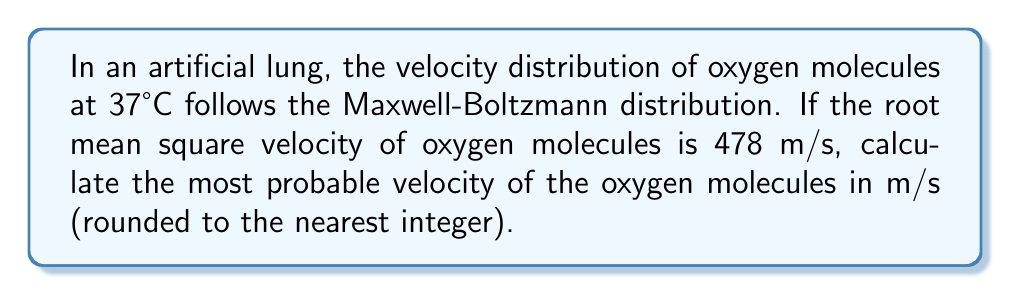Provide a solution to this math problem. To solve this problem, we'll follow these steps:

1) The Maxwell-Boltzmann distribution for molecular velocities is given by:

   $$f(v) = 4\pi \left(\frac{m}{2\pi kT}\right)^{3/2} v^2 e^{-\frac{mv^2}{2kT}}$$

   where $m$ is the mass of the molecule, $k$ is Boltzmann's constant, $T$ is temperature, and $v$ is velocity.

2) The root mean square velocity $v_{rms}$ is related to temperature by:

   $$v_{rms} = \sqrt{\frac{3kT}{m}}$$

3) The most probable velocity $v_p$ is related to $v_{rms}$ by:

   $$v_p = \sqrt{\frac{2}{3}} v_{rms}$$

4) Given $v_{rms} = 478$ m/s, we can calculate $v_p$:

   $$v_p = \sqrt{\frac{2}{3}} \times 478$$

5) Solving this:

   $$v_p = \sqrt{0.6667} \times 478 = 0.8165 \times 478 = 390.287 \text{ m/s}$$

6) Rounding to the nearest integer:

   $$v_p \approx 390 \text{ m/s}$$
Answer: 390 m/s 